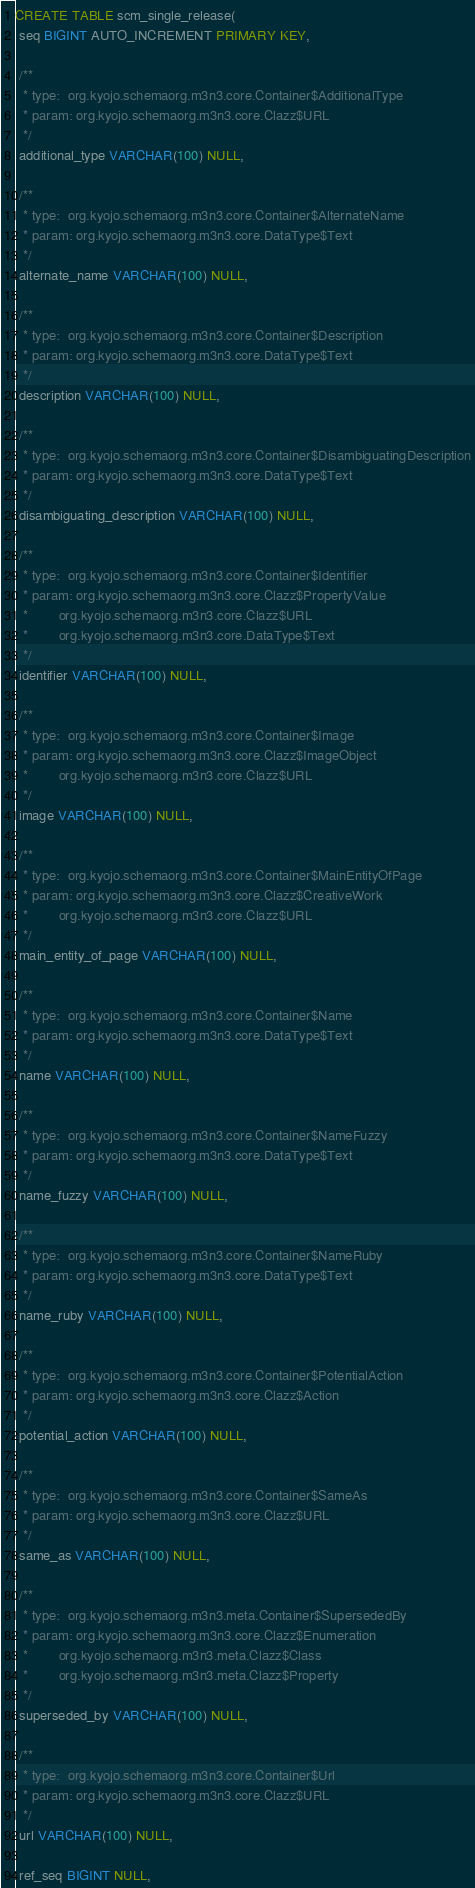Convert code to text. <code><loc_0><loc_0><loc_500><loc_500><_SQL_>CREATE TABLE scm_single_release(
 seq BIGINT AUTO_INCREMENT PRIMARY KEY,

 /**
  * type:  org.kyojo.schemaorg.m3n3.core.Container$AdditionalType
  * param: org.kyojo.schemaorg.m3n3.core.Clazz$URL
  */
 additional_type VARCHAR(100) NULL,

 /**
  * type:  org.kyojo.schemaorg.m3n3.core.Container$AlternateName
  * param: org.kyojo.schemaorg.m3n3.core.DataType$Text
  */
 alternate_name VARCHAR(100) NULL,

 /**
  * type:  org.kyojo.schemaorg.m3n3.core.Container$Description
  * param: org.kyojo.schemaorg.m3n3.core.DataType$Text
  */
 description VARCHAR(100) NULL,

 /**
  * type:  org.kyojo.schemaorg.m3n3.core.Container$DisambiguatingDescription
  * param: org.kyojo.schemaorg.m3n3.core.DataType$Text
  */
 disambiguating_description VARCHAR(100) NULL,

 /**
  * type:  org.kyojo.schemaorg.m3n3.core.Container$Identifier
  * param: org.kyojo.schemaorg.m3n3.core.Clazz$PropertyValue
  *        org.kyojo.schemaorg.m3n3.core.Clazz$URL
  *        org.kyojo.schemaorg.m3n3.core.DataType$Text
  */
 identifier VARCHAR(100) NULL,

 /**
  * type:  org.kyojo.schemaorg.m3n3.core.Container$Image
  * param: org.kyojo.schemaorg.m3n3.core.Clazz$ImageObject
  *        org.kyojo.schemaorg.m3n3.core.Clazz$URL
  */
 image VARCHAR(100) NULL,

 /**
  * type:  org.kyojo.schemaorg.m3n3.core.Container$MainEntityOfPage
  * param: org.kyojo.schemaorg.m3n3.core.Clazz$CreativeWork
  *        org.kyojo.schemaorg.m3n3.core.Clazz$URL
  */
 main_entity_of_page VARCHAR(100) NULL,

 /**
  * type:  org.kyojo.schemaorg.m3n3.core.Container$Name
  * param: org.kyojo.schemaorg.m3n3.core.DataType$Text
  */
 name VARCHAR(100) NULL,

 /**
  * type:  org.kyojo.schemaorg.m3n3.core.Container$NameFuzzy
  * param: org.kyojo.schemaorg.m3n3.core.DataType$Text
  */
 name_fuzzy VARCHAR(100) NULL,

 /**
  * type:  org.kyojo.schemaorg.m3n3.core.Container$NameRuby
  * param: org.kyojo.schemaorg.m3n3.core.DataType$Text
  */
 name_ruby VARCHAR(100) NULL,

 /**
  * type:  org.kyojo.schemaorg.m3n3.core.Container$PotentialAction
  * param: org.kyojo.schemaorg.m3n3.core.Clazz$Action
  */
 potential_action VARCHAR(100) NULL,

 /**
  * type:  org.kyojo.schemaorg.m3n3.core.Container$SameAs
  * param: org.kyojo.schemaorg.m3n3.core.Clazz$URL
  */
 same_as VARCHAR(100) NULL,

 /**
  * type:  org.kyojo.schemaorg.m3n3.meta.Container$SupersededBy
  * param: org.kyojo.schemaorg.m3n3.core.Clazz$Enumeration
  *        org.kyojo.schemaorg.m3n3.meta.Clazz$Class
  *        org.kyojo.schemaorg.m3n3.meta.Clazz$Property
  */
 superseded_by VARCHAR(100) NULL,

 /**
  * type:  org.kyojo.schemaorg.m3n3.core.Container$Url
  * param: org.kyojo.schemaorg.m3n3.core.Clazz$URL
  */
 url VARCHAR(100) NULL,

 ref_seq BIGINT NULL,</code> 